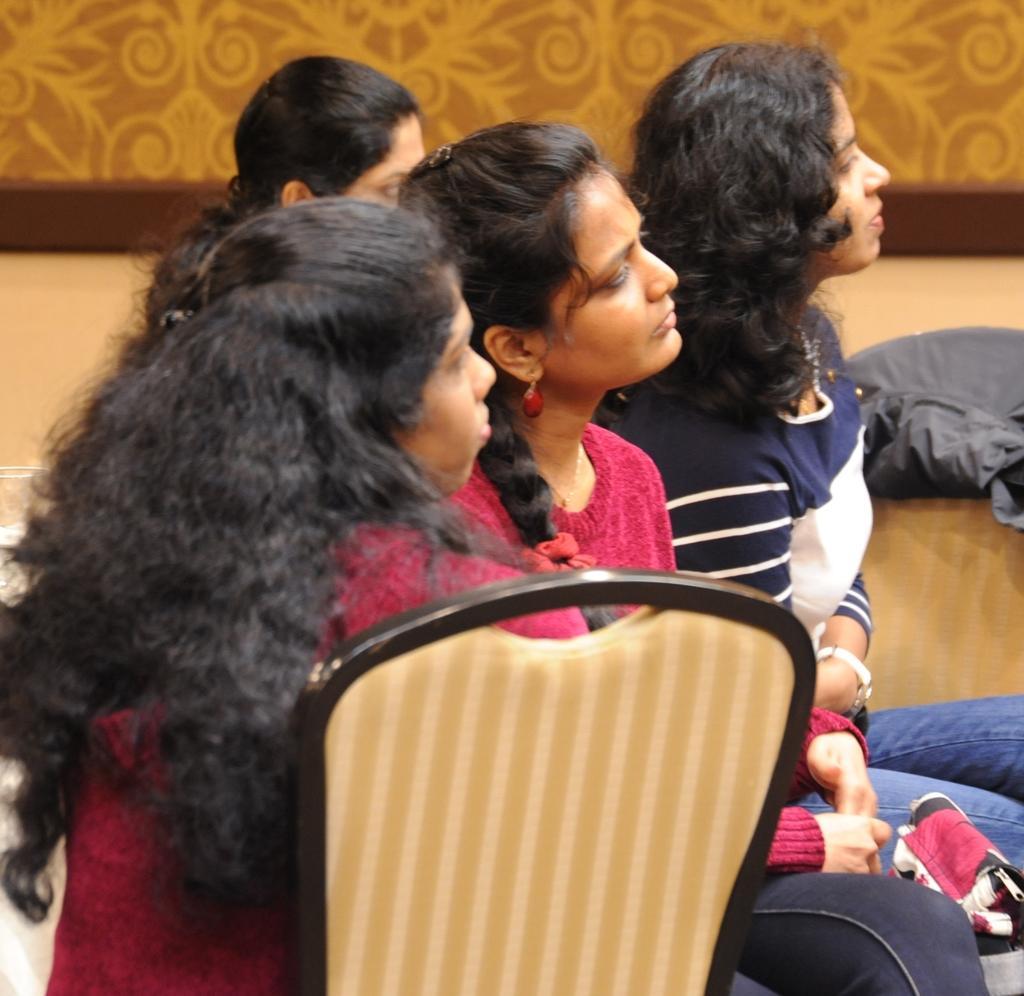How would you summarize this image in a sentence or two? In the picture we can see some group of women sitting on chairs and in the background there is a wall. 